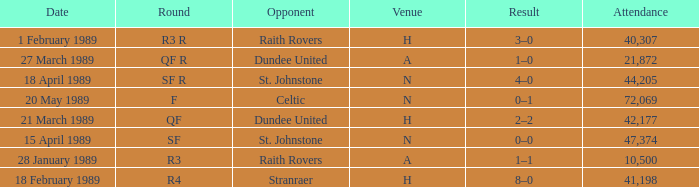What is the specific date for the round in sf? 15 April 1989. 